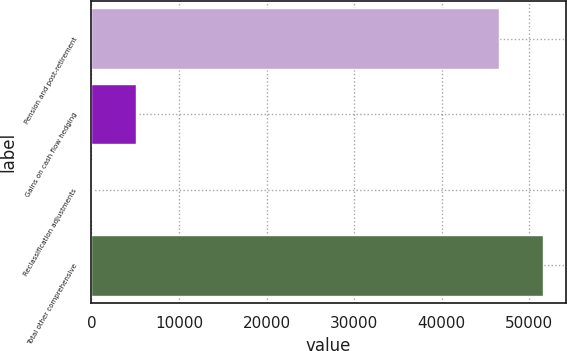<chart> <loc_0><loc_0><loc_500><loc_500><bar_chart><fcel>Pension and post-retirement<fcel>Gains on cash flow hedging<fcel>Reclassification adjustments<fcel>Total other comprehensive<nl><fcel>46535<fcel>5116.3<fcel>79<fcel>51572.3<nl></chart> 